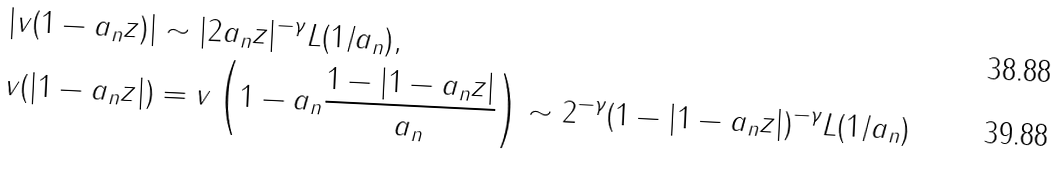Convert formula to latex. <formula><loc_0><loc_0><loc_500><loc_500>| v ( 1 - a _ { n } z ) | & \sim | 2 a _ { n } z | ^ { - \gamma } L ( 1 / a _ { n } ) , \\ v ( | 1 - a _ { n } z | ) & = v \left ( 1 - a _ { n } \frac { 1 - | 1 - a _ { n } z | } { a _ { n } } \right ) \sim 2 ^ { - \gamma } ( 1 - | 1 - a _ { n } z | ) ^ { - \gamma } L ( 1 / a _ { n } )</formula> 